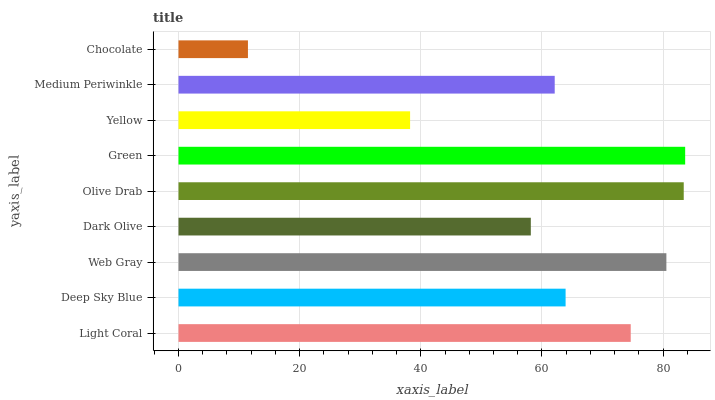Is Chocolate the minimum?
Answer yes or no. Yes. Is Green the maximum?
Answer yes or no. Yes. Is Deep Sky Blue the minimum?
Answer yes or no. No. Is Deep Sky Blue the maximum?
Answer yes or no. No. Is Light Coral greater than Deep Sky Blue?
Answer yes or no. Yes. Is Deep Sky Blue less than Light Coral?
Answer yes or no. Yes. Is Deep Sky Blue greater than Light Coral?
Answer yes or no. No. Is Light Coral less than Deep Sky Blue?
Answer yes or no. No. Is Deep Sky Blue the high median?
Answer yes or no. Yes. Is Deep Sky Blue the low median?
Answer yes or no. Yes. Is Yellow the high median?
Answer yes or no. No. Is Green the low median?
Answer yes or no. No. 